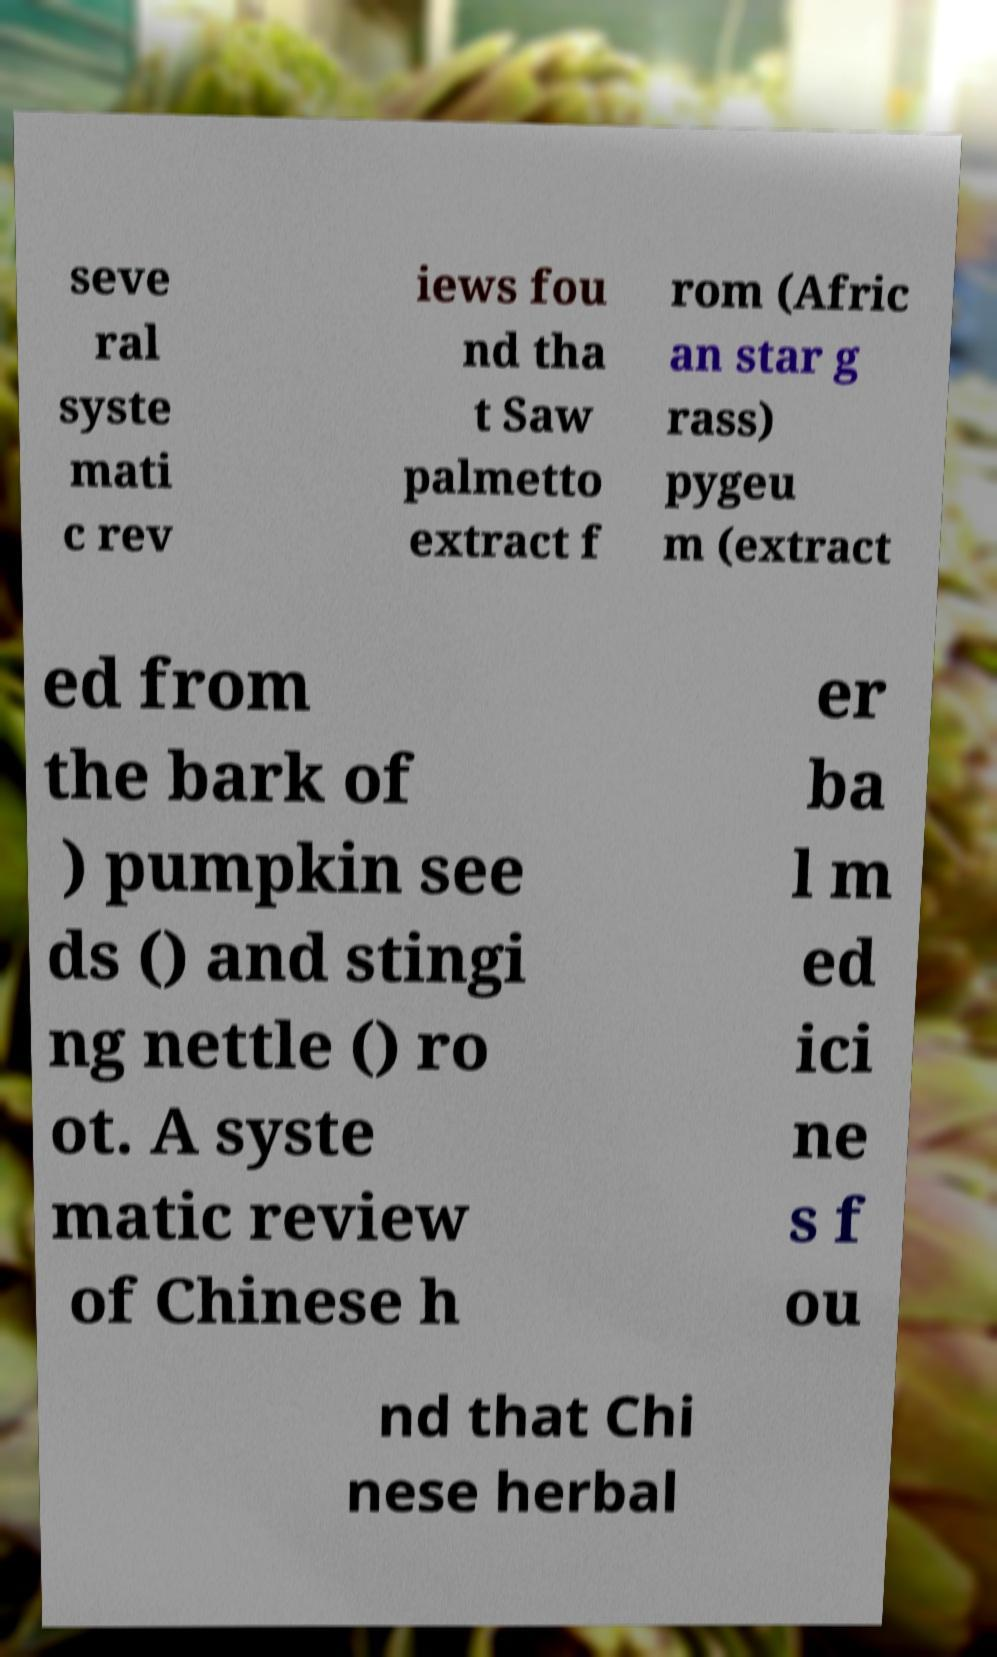Could you extract and type out the text from this image? seve ral syste mati c rev iews fou nd tha t Saw palmetto extract f rom (Afric an star g rass) pygeu m (extract ed from the bark of ) pumpkin see ds () and stingi ng nettle () ro ot. A syste matic review of Chinese h er ba l m ed ici ne s f ou nd that Chi nese herbal 